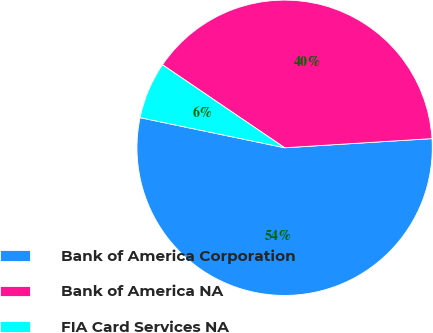Convert chart. <chart><loc_0><loc_0><loc_500><loc_500><pie_chart><fcel>Bank of America Corporation<fcel>Bank of America NA<fcel>FIA Card Services NA<nl><fcel>54.25%<fcel>39.51%<fcel>6.23%<nl></chart> 